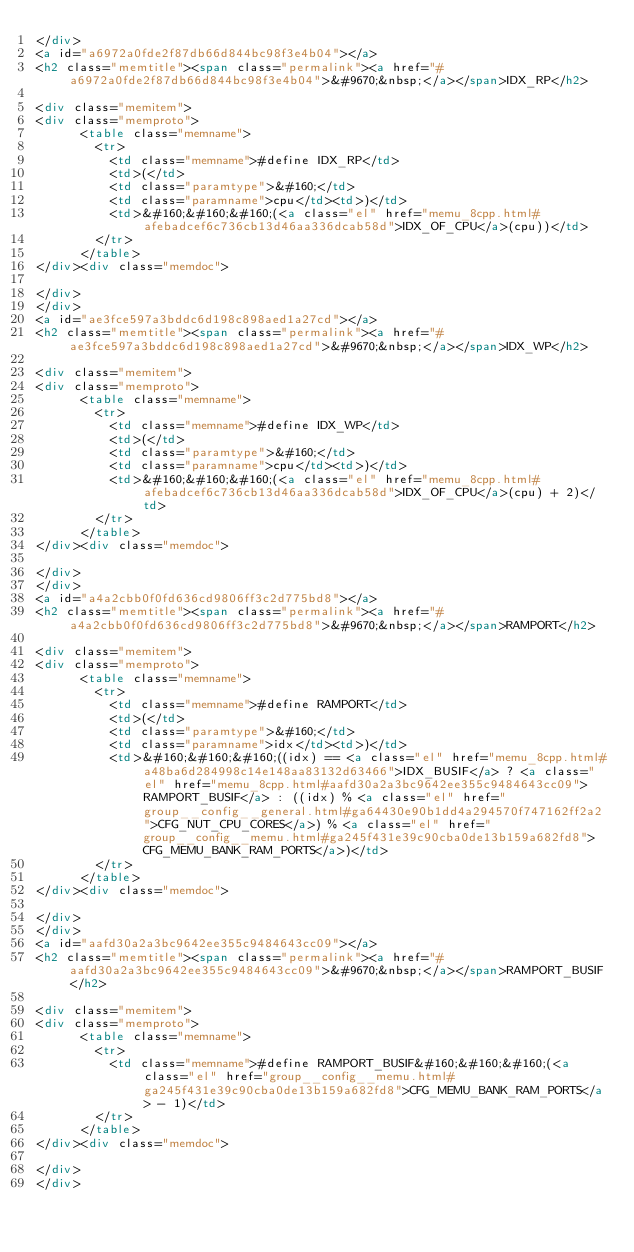<code> <loc_0><loc_0><loc_500><loc_500><_HTML_></div>
<a id="a6972a0fde2f87db66d844bc98f3e4b04"></a>
<h2 class="memtitle"><span class="permalink"><a href="#a6972a0fde2f87db66d844bc98f3e4b04">&#9670;&nbsp;</a></span>IDX_RP</h2>

<div class="memitem">
<div class="memproto">
      <table class="memname">
        <tr>
          <td class="memname">#define IDX_RP</td>
          <td>(</td>
          <td class="paramtype">&#160;</td>
          <td class="paramname">cpu</td><td>)</td>
          <td>&#160;&#160;&#160;(<a class="el" href="memu_8cpp.html#afebadcef6c736cb13d46aa336dcab58d">IDX_OF_CPU</a>(cpu))</td>
        </tr>
      </table>
</div><div class="memdoc">

</div>
</div>
<a id="ae3fce597a3bddc6d198c898aed1a27cd"></a>
<h2 class="memtitle"><span class="permalink"><a href="#ae3fce597a3bddc6d198c898aed1a27cd">&#9670;&nbsp;</a></span>IDX_WP</h2>

<div class="memitem">
<div class="memproto">
      <table class="memname">
        <tr>
          <td class="memname">#define IDX_WP</td>
          <td>(</td>
          <td class="paramtype">&#160;</td>
          <td class="paramname">cpu</td><td>)</td>
          <td>&#160;&#160;&#160;(<a class="el" href="memu_8cpp.html#afebadcef6c736cb13d46aa336dcab58d">IDX_OF_CPU</a>(cpu) + 2)</td>
        </tr>
      </table>
</div><div class="memdoc">

</div>
</div>
<a id="a4a2cbb0f0fd636cd9806ff3c2d775bd8"></a>
<h2 class="memtitle"><span class="permalink"><a href="#a4a2cbb0f0fd636cd9806ff3c2d775bd8">&#9670;&nbsp;</a></span>RAMPORT</h2>

<div class="memitem">
<div class="memproto">
      <table class="memname">
        <tr>
          <td class="memname">#define RAMPORT</td>
          <td>(</td>
          <td class="paramtype">&#160;</td>
          <td class="paramname">idx</td><td>)</td>
          <td>&#160;&#160;&#160;((idx) == <a class="el" href="memu_8cpp.html#a48ba6d284998c14e148aa83132d63466">IDX_BUSIF</a> ? <a class="el" href="memu_8cpp.html#aafd30a2a3bc9642ee355c9484643cc09">RAMPORT_BUSIF</a> : ((idx) % <a class="el" href="group__config__general.html#ga64430e90b1dd4a294570f747162ff2a2">CFG_NUT_CPU_CORES</a>) % <a class="el" href="group__config__memu.html#ga245f431e39c90cba0de13b159a682fd8">CFG_MEMU_BANK_RAM_PORTS</a>)</td>
        </tr>
      </table>
</div><div class="memdoc">

</div>
</div>
<a id="aafd30a2a3bc9642ee355c9484643cc09"></a>
<h2 class="memtitle"><span class="permalink"><a href="#aafd30a2a3bc9642ee355c9484643cc09">&#9670;&nbsp;</a></span>RAMPORT_BUSIF</h2>

<div class="memitem">
<div class="memproto">
      <table class="memname">
        <tr>
          <td class="memname">#define RAMPORT_BUSIF&#160;&#160;&#160;(<a class="el" href="group__config__memu.html#ga245f431e39c90cba0de13b159a682fd8">CFG_MEMU_BANK_RAM_PORTS</a> - 1)</td>
        </tr>
      </table>
</div><div class="memdoc">

</div>
</div></code> 